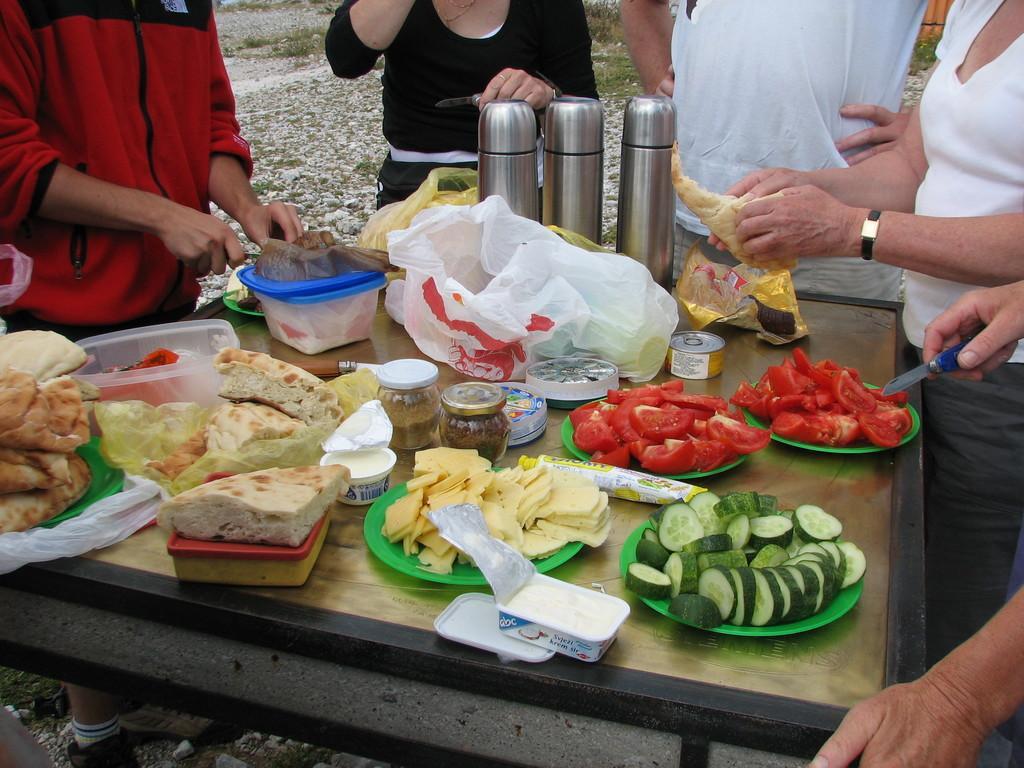Can you describe this image briefly? In this image there is a table, on that table there are plates, in that plates there are vegetables and other food items, around the table there are five persons standing. 